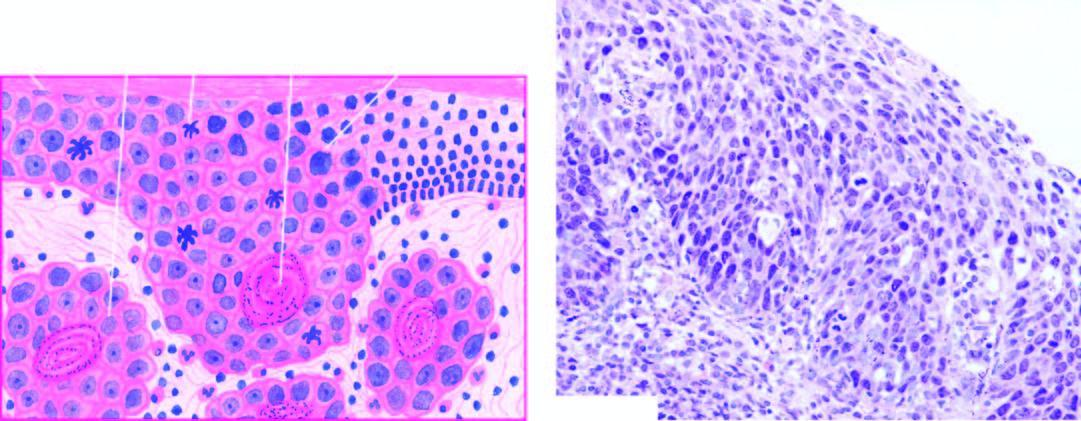do the squamous cells show superficial invasive islands of malignant cells in the subepithelial soft tissues?
Answer the question using a single word or phrase. No 